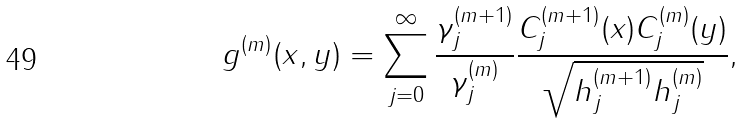<formula> <loc_0><loc_0><loc_500><loc_500>g ^ { ( m ) } ( x , y ) = \sum _ { j = 0 } ^ { \infty } \frac { \gamma ^ { ( m + 1 ) } _ { j } } { \gamma ^ { ( m ) } _ { j } } \frac { C ^ { ( m + 1 ) } _ { j } ( x ) C ^ { ( m ) } _ { j } ( y ) } { \sqrt { h ^ { ( m + 1 ) } _ { j } h ^ { ( m ) } _ { j } } } ,</formula> 